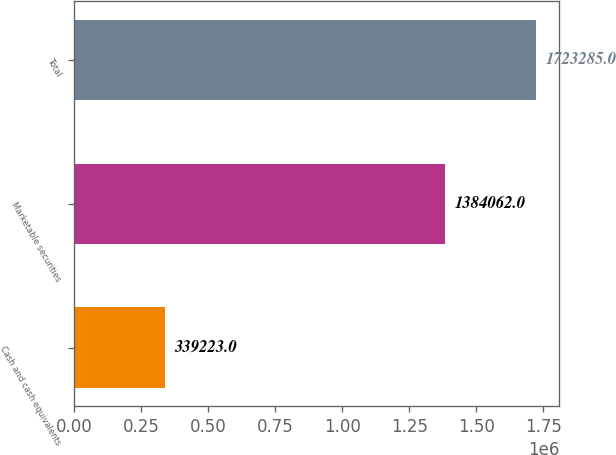<chart> <loc_0><loc_0><loc_500><loc_500><bar_chart><fcel>Cash and cash equivalents<fcel>Marketable securities<fcel>Total<nl><fcel>339223<fcel>1.38406e+06<fcel>1.72328e+06<nl></chart> 